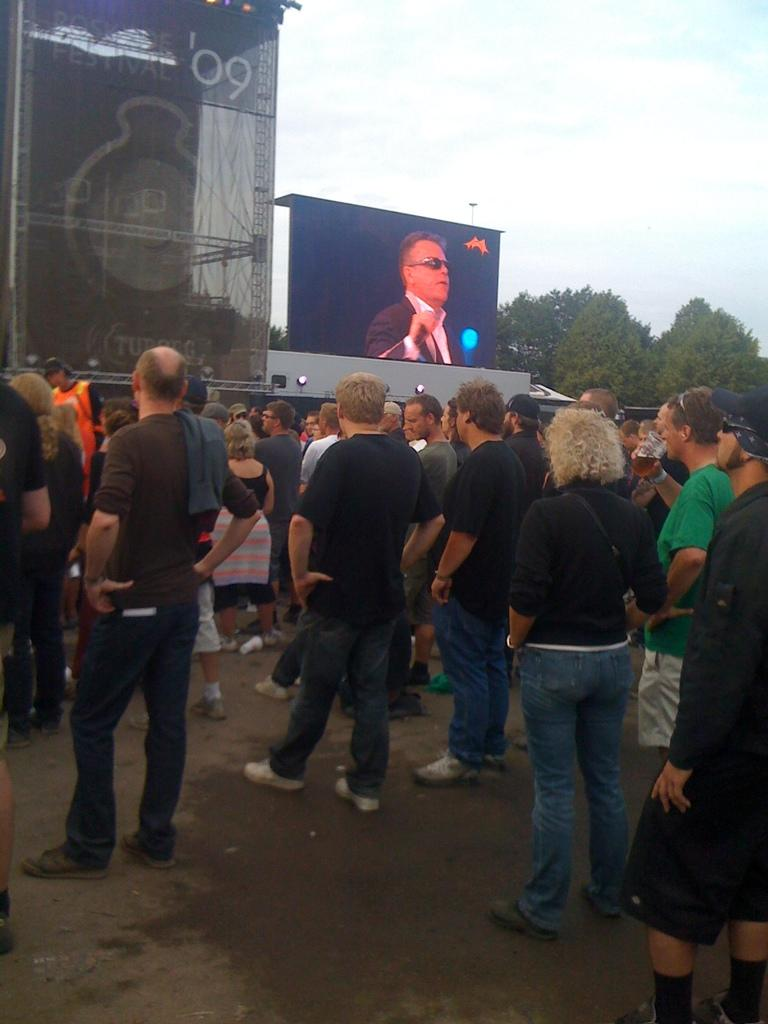What is happening with the people in the image? There are people standing in the image. What can be seen in the background of the image? There is a hoarding in the image, and trees are visible. What is the man holding in his hand? The man is holding a glass in his hand. What is the man doing with the glass? The man is drinking from the glass. How would you describe the sky in the image? The sky is blue and cloudy. What type of bike is being used to collect honey in the image? There is no bike or honey present in the image. How does the dust affect the people in the image? There is no mention of dust in the image, so it cannot affect the people. 